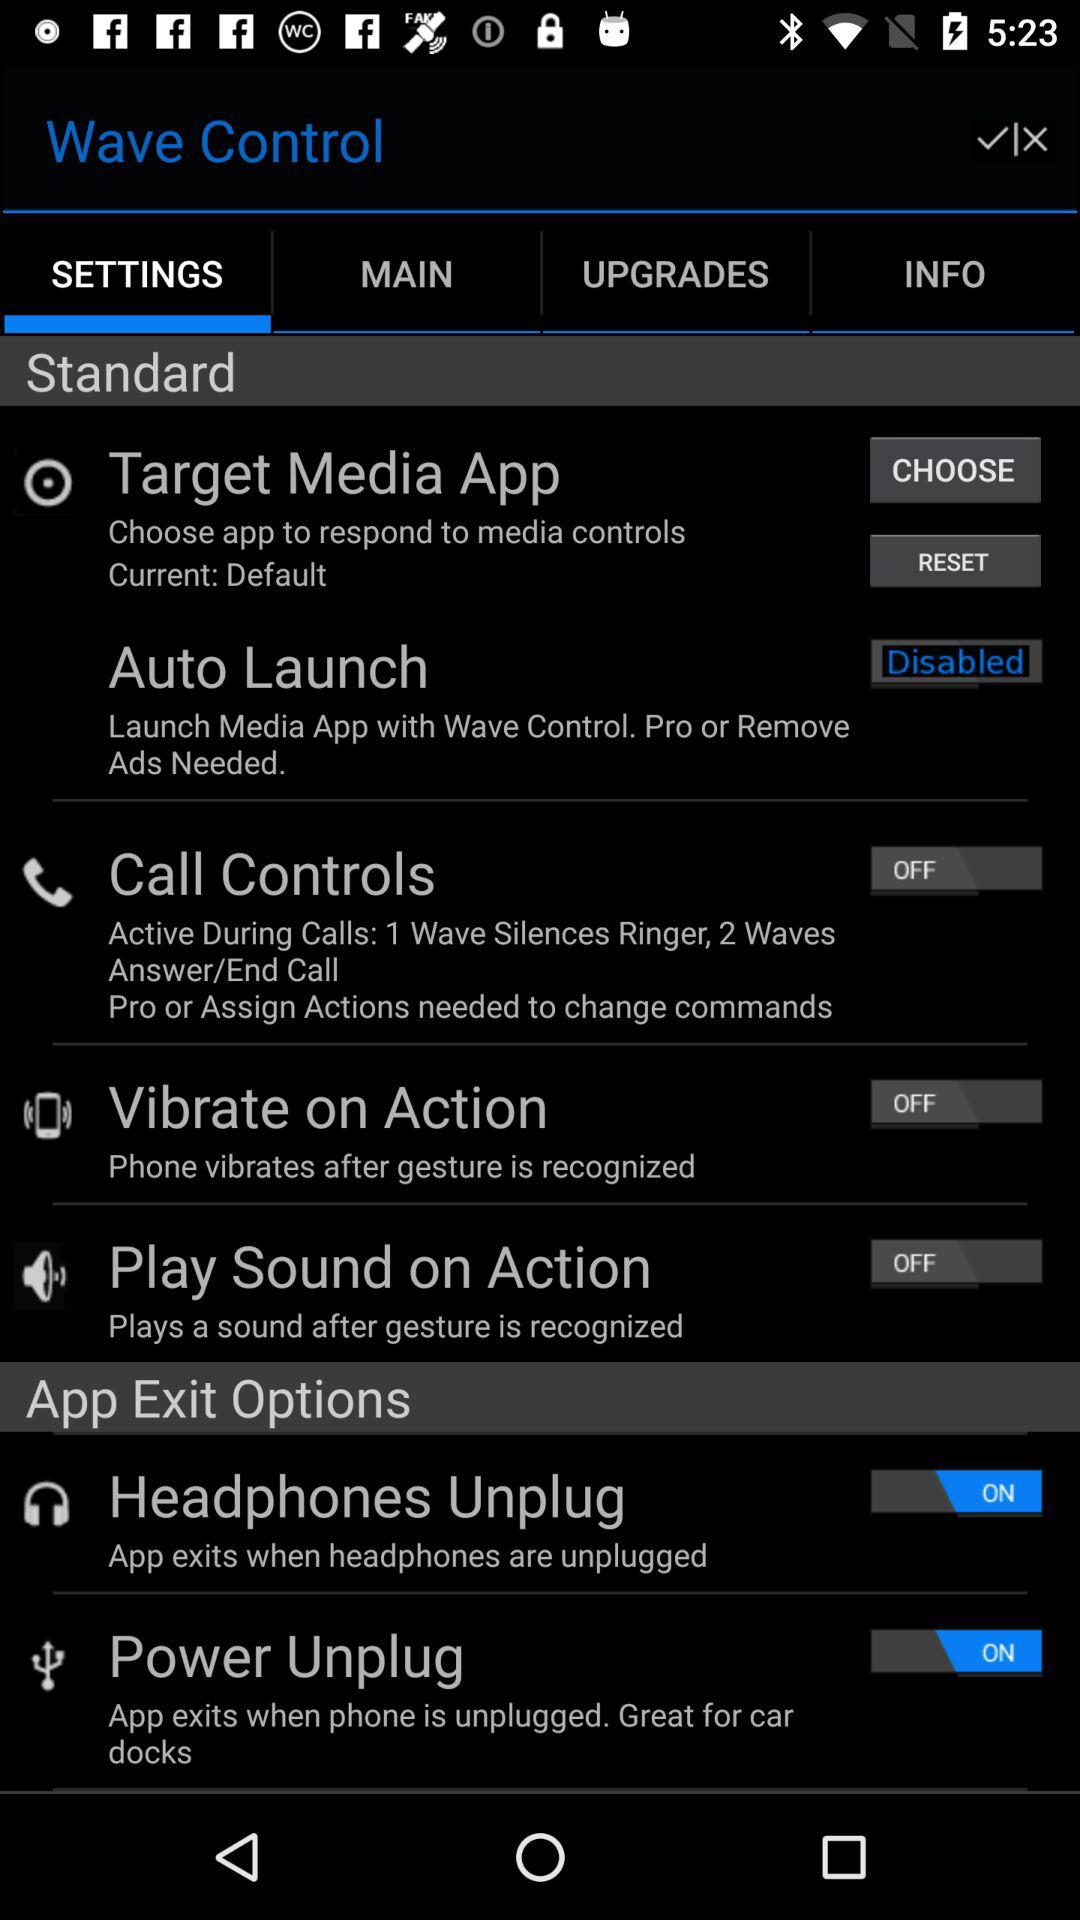How many of the app exit options have switches?
Answer the question using a single word or phrase. 2 